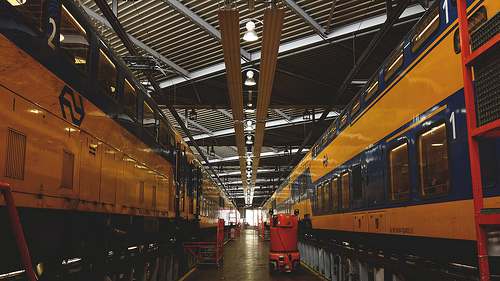<image>
Is the train to the left of the train? No. The train is not to the left of the train. From this viewpoint, they have a different horizontal relationship. 